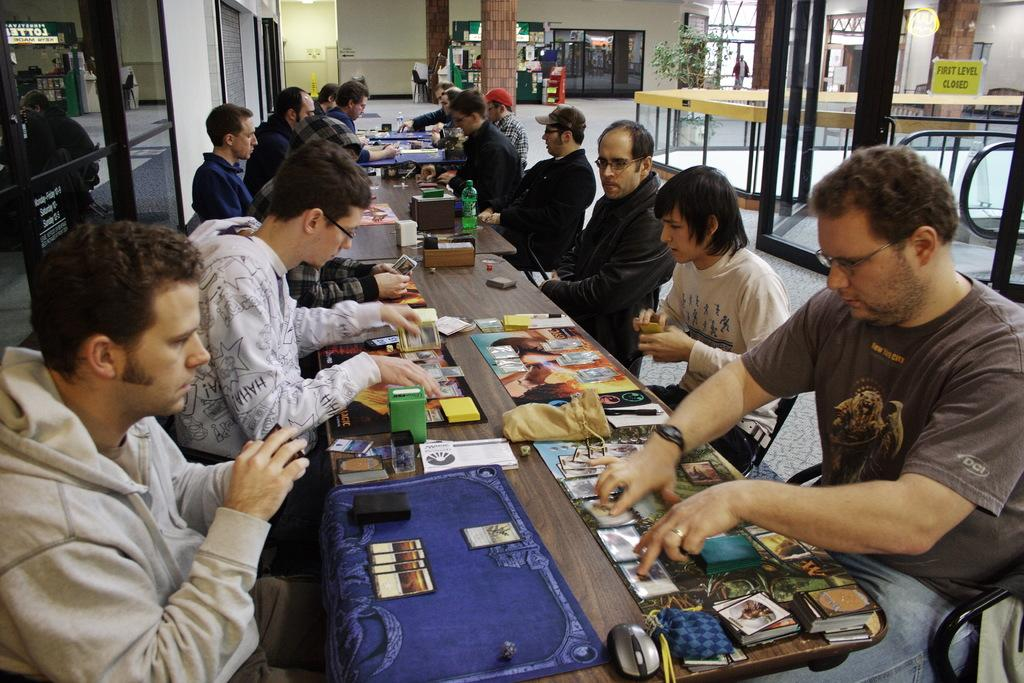Who is present in the image? There are people in the image. What are the people doing in the image? The people are sitting around a table. What type of stamp can be seen on the table in the image? There is no stamp present in the image; it only shows people sitting around a table. 